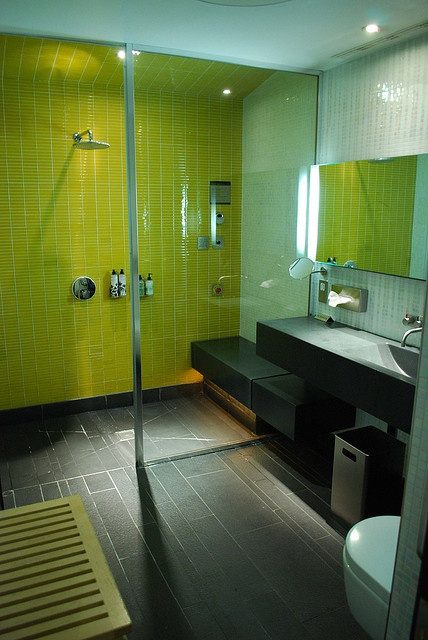Describe the objects in this image and their specific colors. I can see bench in teal, black, and darkgreen tones, toilet in teal, black, darkgray, and darkgreen tones, and sink in teal, black, and gray tones in this image. 